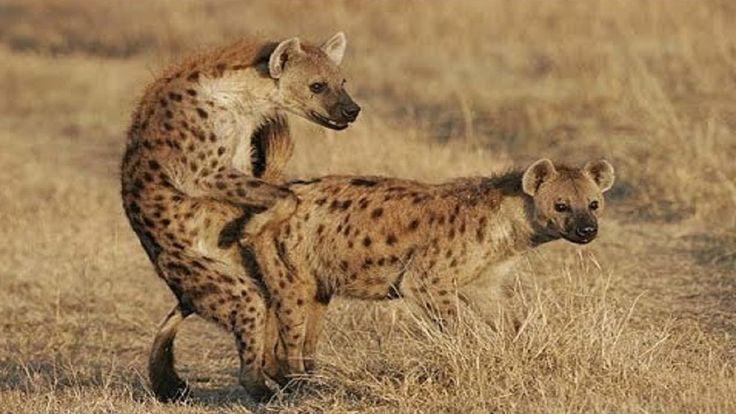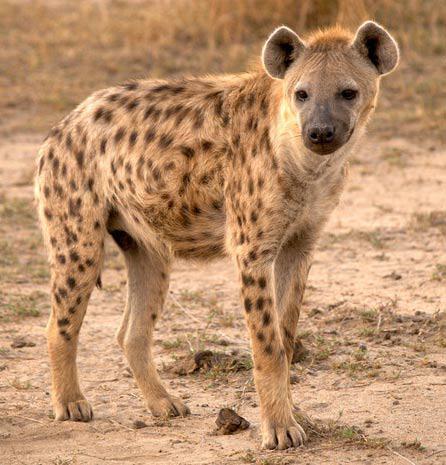The first image is the image on the left, the second image is the image on the right. For the images displayed, is the sentence "At least one image shows a single hyena with its mouth partly open showing teeth." factually correct? Answer yes or no. No. 